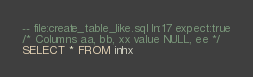Convert code to text. <code><loc_0><loc_0><loc_500><loc_500><_SQL_>-- file:create_table_like.sql ln:17 expect:true
/* Columns aa, bb, xx value NULL, ee */
SELECT * FROM inhx
</code> 